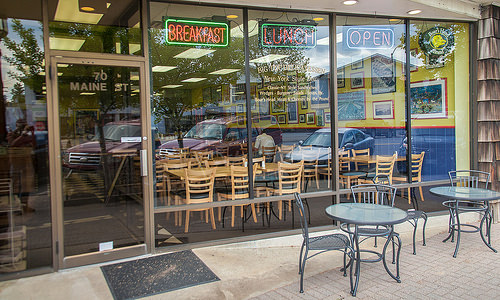<image>
Is the door in front of the picture? Yes. The door is positioned in front of the picture, appearing closer to the camera viewpoint. Where is the glass in relation to the table? Is it in front of the table? Yes. The glass is positioned in front of the table, appearing closer to the camera viewpoint. 